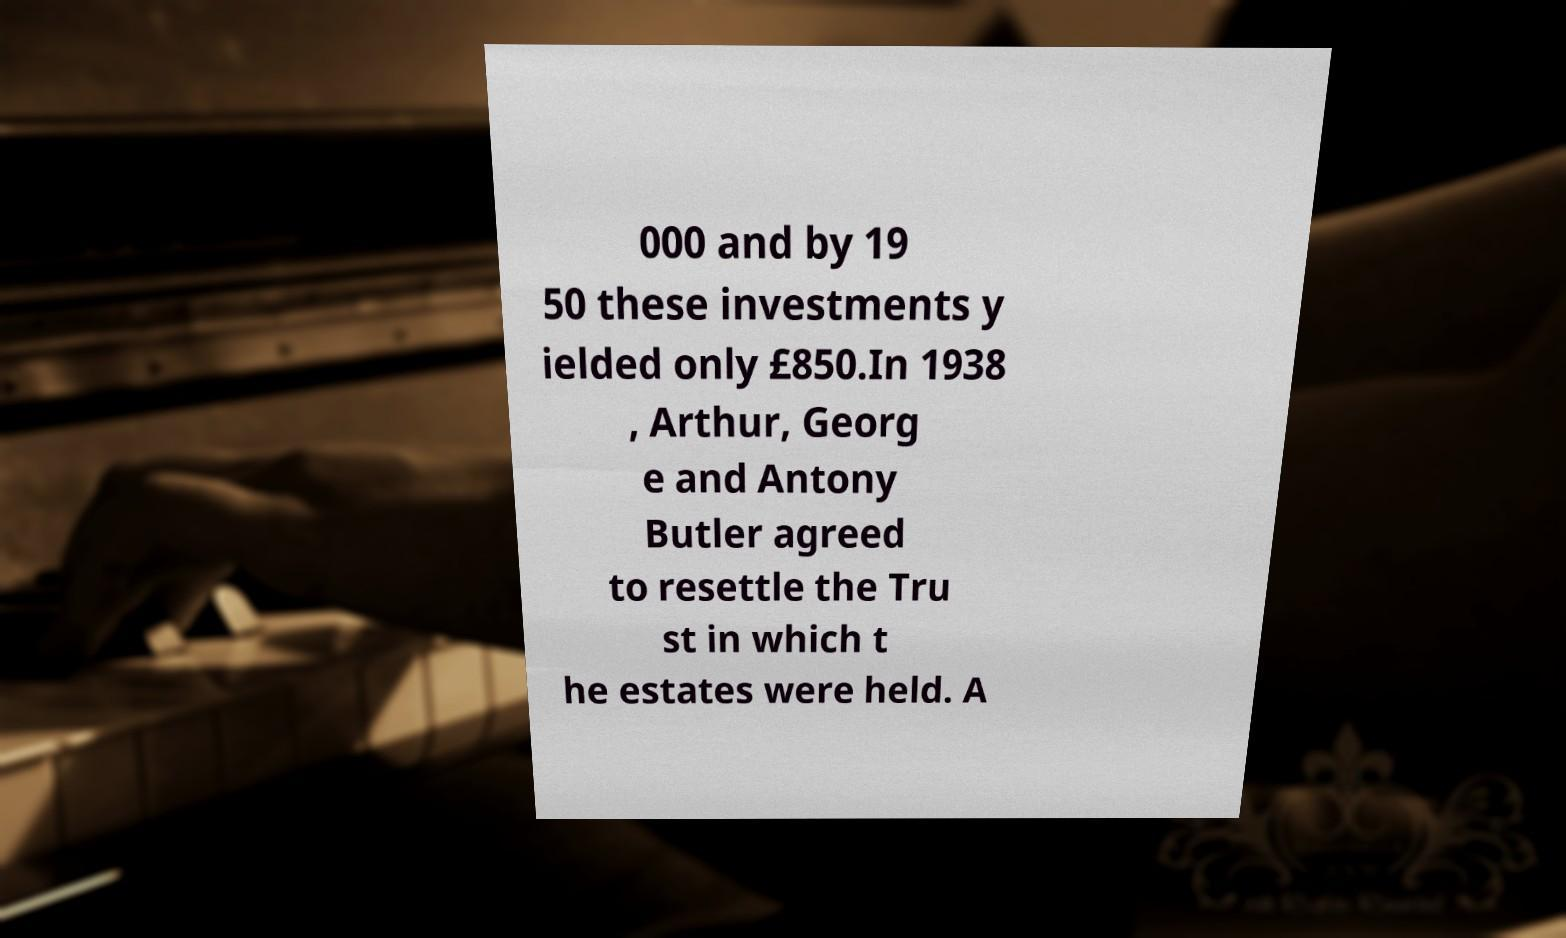There's text embedded in this image that I need extracted. Can you transcribe it verbatim? 000 and by 19 50 these investments y ielded only £850.In 1938 , Arthur, Georg e and Antony Butler agreed to resettle the Tru st in which t he estates were held. A 